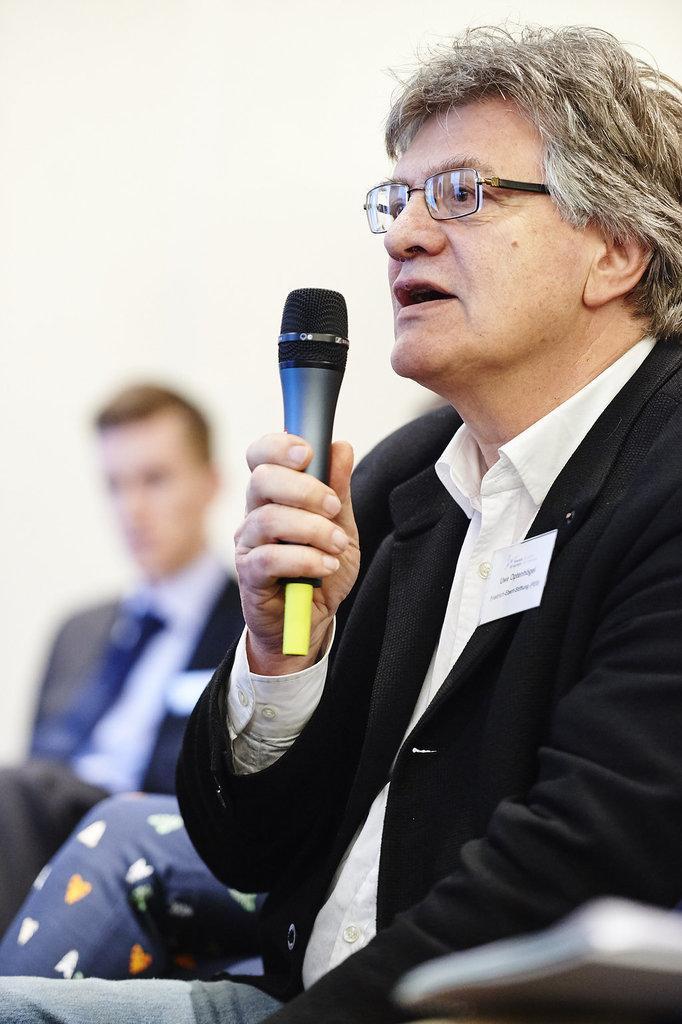How would you summarize this image in a sentence or two? One person is holding a microphone and wearing glasses beside him there are two people. 